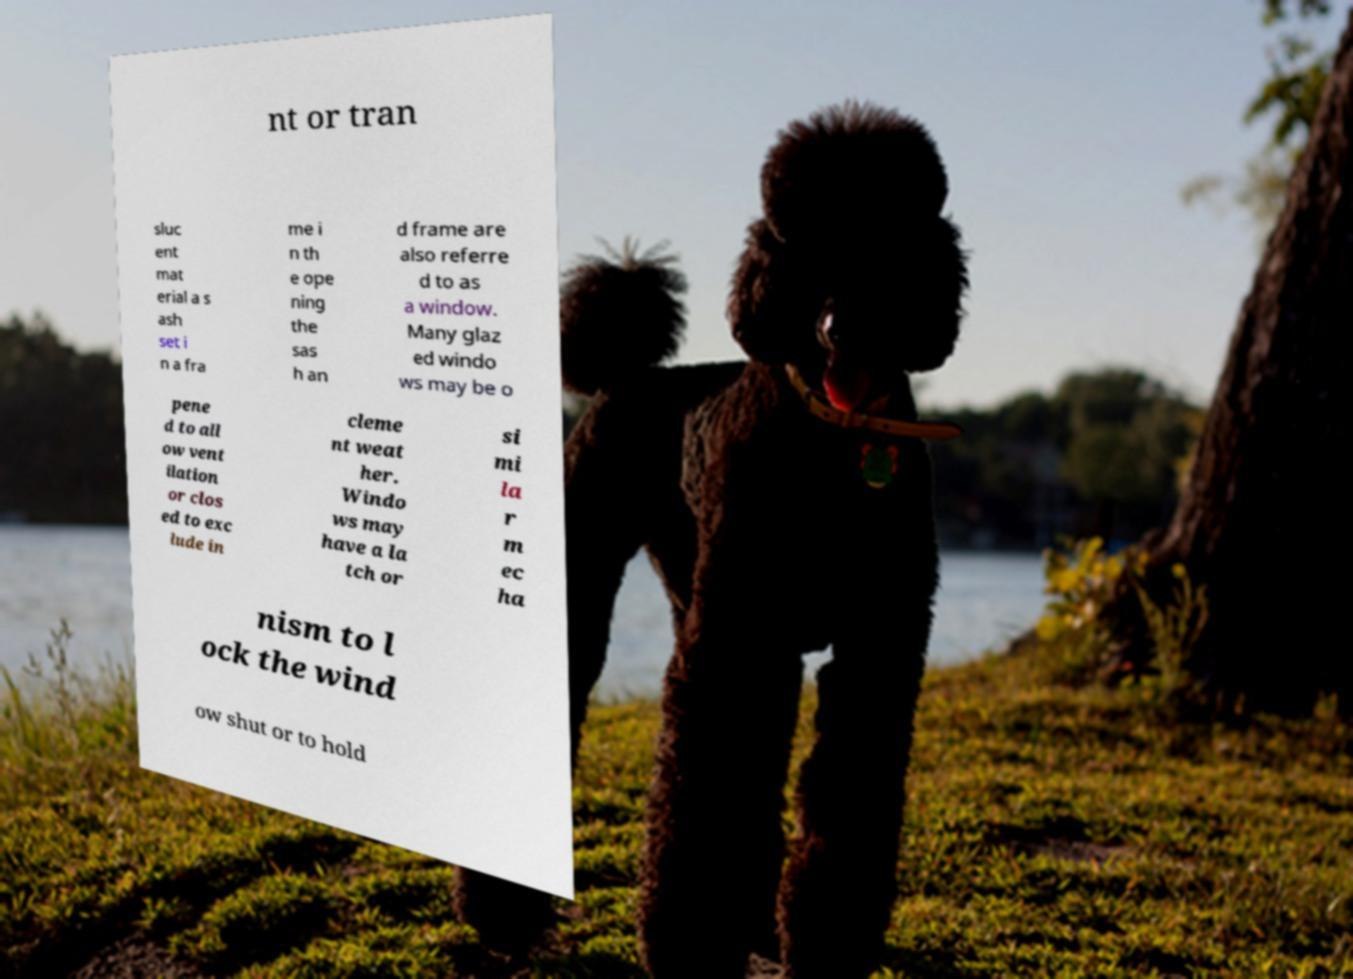There's text embedded in this image that I need extracted. Can you transcribe it verbatim? nt or tran sluc ent mat erial a s ash set i n a fra me i n th e ope ning the sas h an d frame are also referre d to as a window. Many glaz ed windo ws may be o pene d to all ow vent ilation or clos ed to exc lude in cleme nt weat her. Windo ws may have a la tch or si mi la r m ec ha nism to l ock the wind ow shut or to hold 